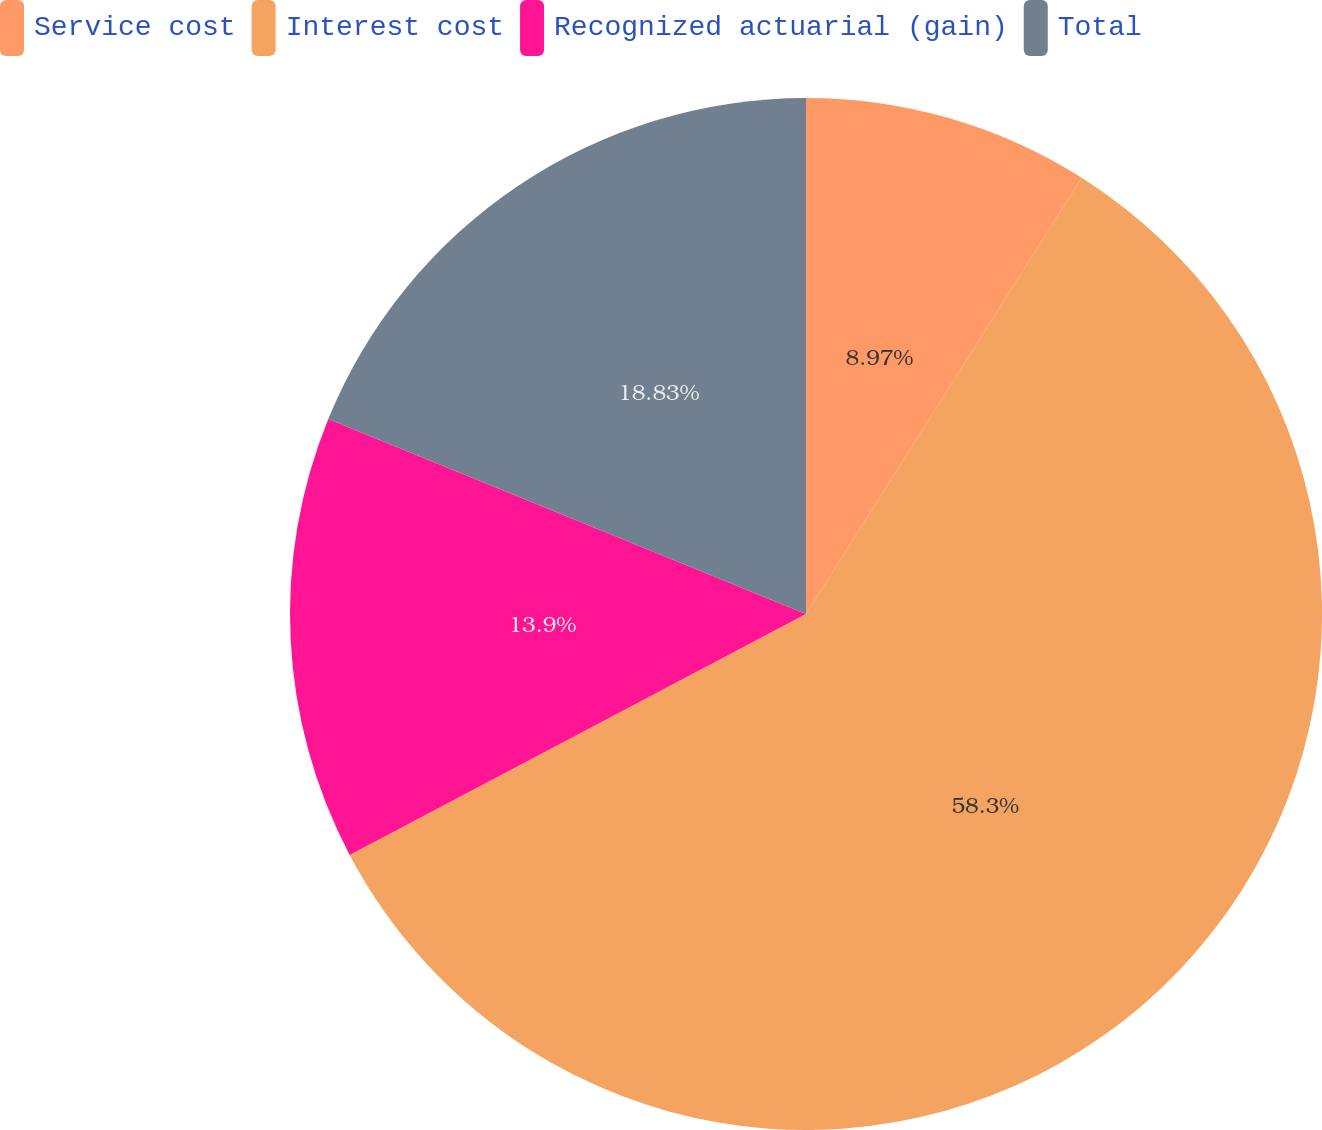<chart> <loc_0><loc_0><loc_500><loc_500><pie_chart><fcel>Service cost<fcel>Interest cost<fcel>Recognized actuarial (gain)<fcel>Total<nl><fcel>8.97%<fcel>58.3%<fcel>13.9%<fcel>18.83%<nl></chart> 